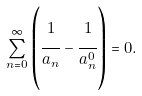<formula> <loc_0><loc_0><loc_500><loc_500>\sum _ { n = 0 } ^ { \infty } \left ( \cfrac { 1 } { a _ { n } } - \cfrac { 1 } { a _ { n } ^ { 0 } } \right ) = 0 .</formula> 